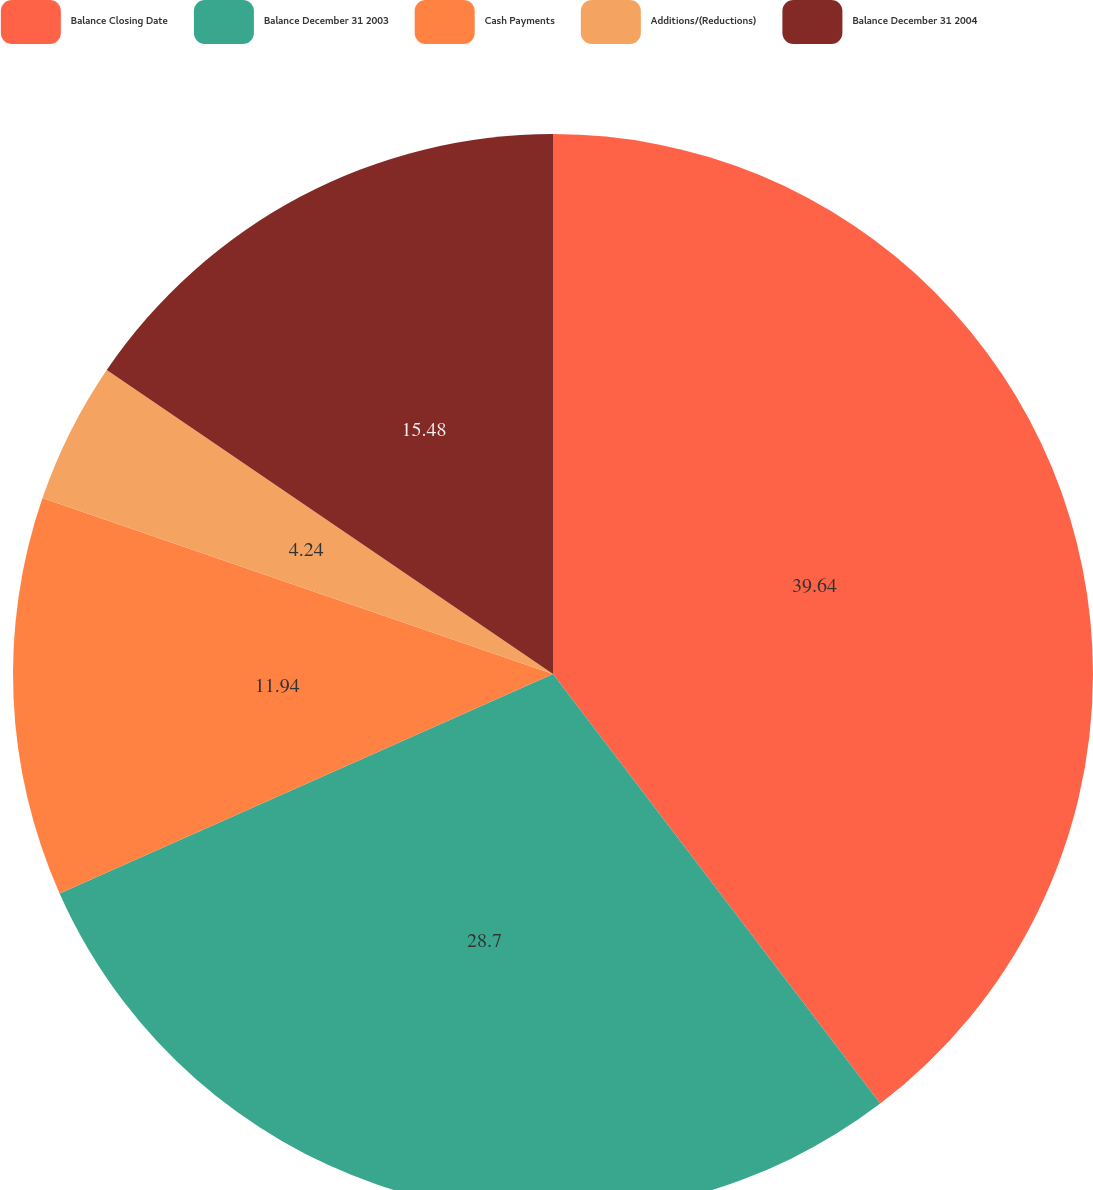Convert chart. <chart><loc_0><loc_0><loc_500><loc_500><pie_chart><fcel>Balance Closing Date<fcel>Balance December 31 2003<fcel>Cash Payments<fcel>Additions/(Reductions)<fcel>Balance December 31 2004<nl><fcel>39.64%<fcel>28.7%<fcel>11.94%<fcel>4.24%<fcel>15.48%<nl></chart> 